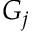<formula> <loc_0><loc_0><loc_500><loc_500>G _ { j }</formula> 